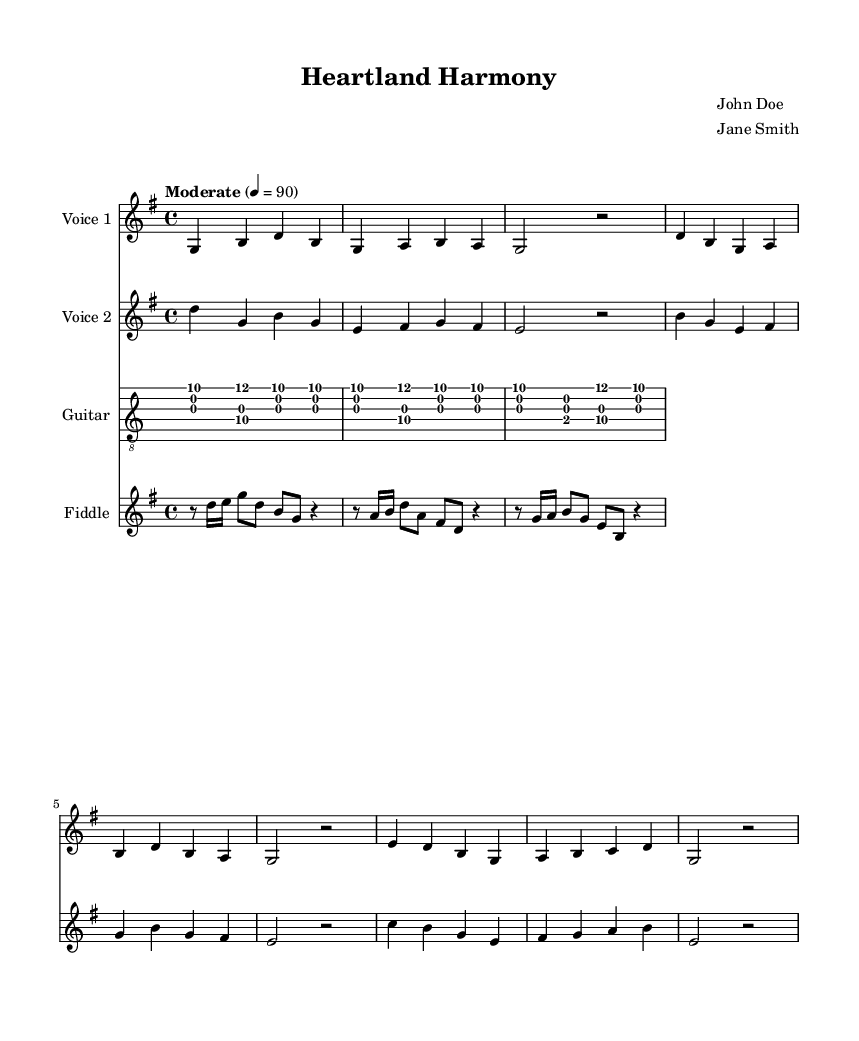What is the key signature of this music? The key signature is G major, which has one sharp (F#). This can be identified from the beginning of the score where the sharp is notated.
Answer: G major What is the time signature of this music? The time signature is 4/4, which indicates there are four beats in a measure and the quarter note gets one beat. It is clearly presented at the beginning of the score.
Answer: 4/4 What is the tempo marking for this piece? The tempo marking is "Moderate" with a metronome marking of 90 beats per minute. This is stated at the beginning of the score.
Answer: Moderate How many measures does the first voice part contain? The first voice part contains six measures, which can be counted in the notation of voiceOne throughout the score.
Answer: Six What instruments are featured in this piece? The instruments featured are Voice 1, Voice 2, Guitar, and Fiddle, as seen in the individual staff names included in the score.
Answer: Voice 1, Voice 2, Guitar, and Fiddle Which voice part sings the lower notes? Voice 2 sings the lower notes, which can be discerned from comparing the pitch of notes in both voice parts. Voice 2 is written an octave lower than Voice 1.
Answer: Voice 2 How many different instruments are used in this arrangement? There are four different instruments used in this arrangement: two vocal parts, guitar, and fiddle. This can be verified by the different staves labeled for each instrument.
Answer: Four 